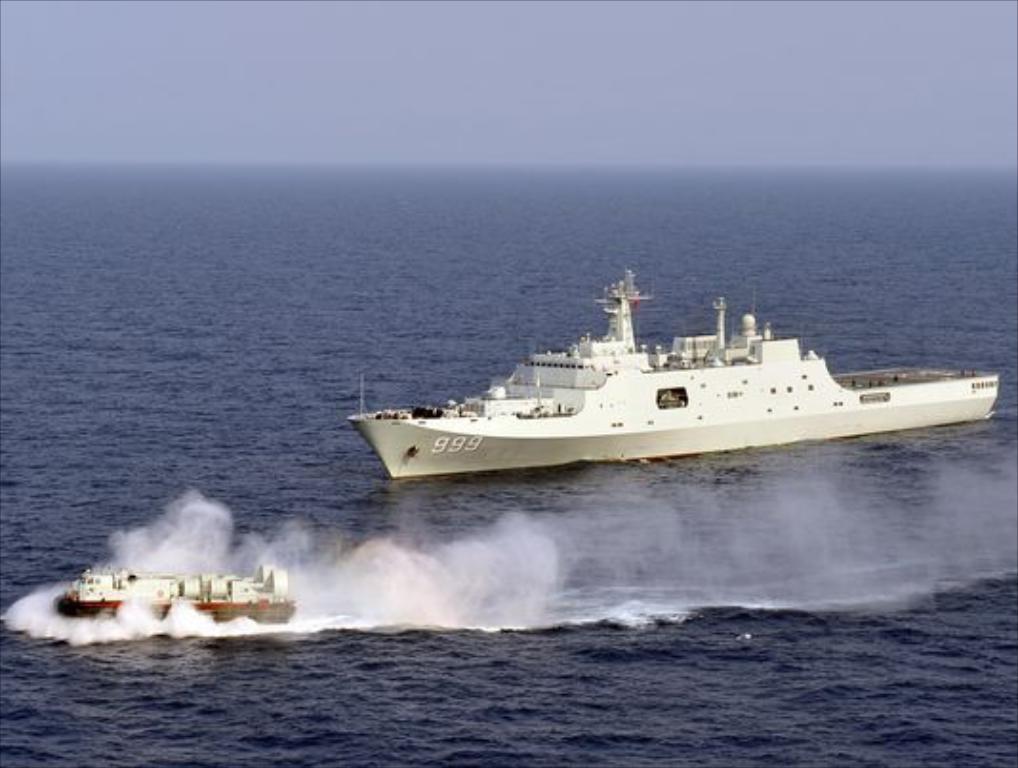How would you summarize this image in a sentence or two? Here in this picture we can see a ship and a boat present in the water and we can see the sky is cloudy. 